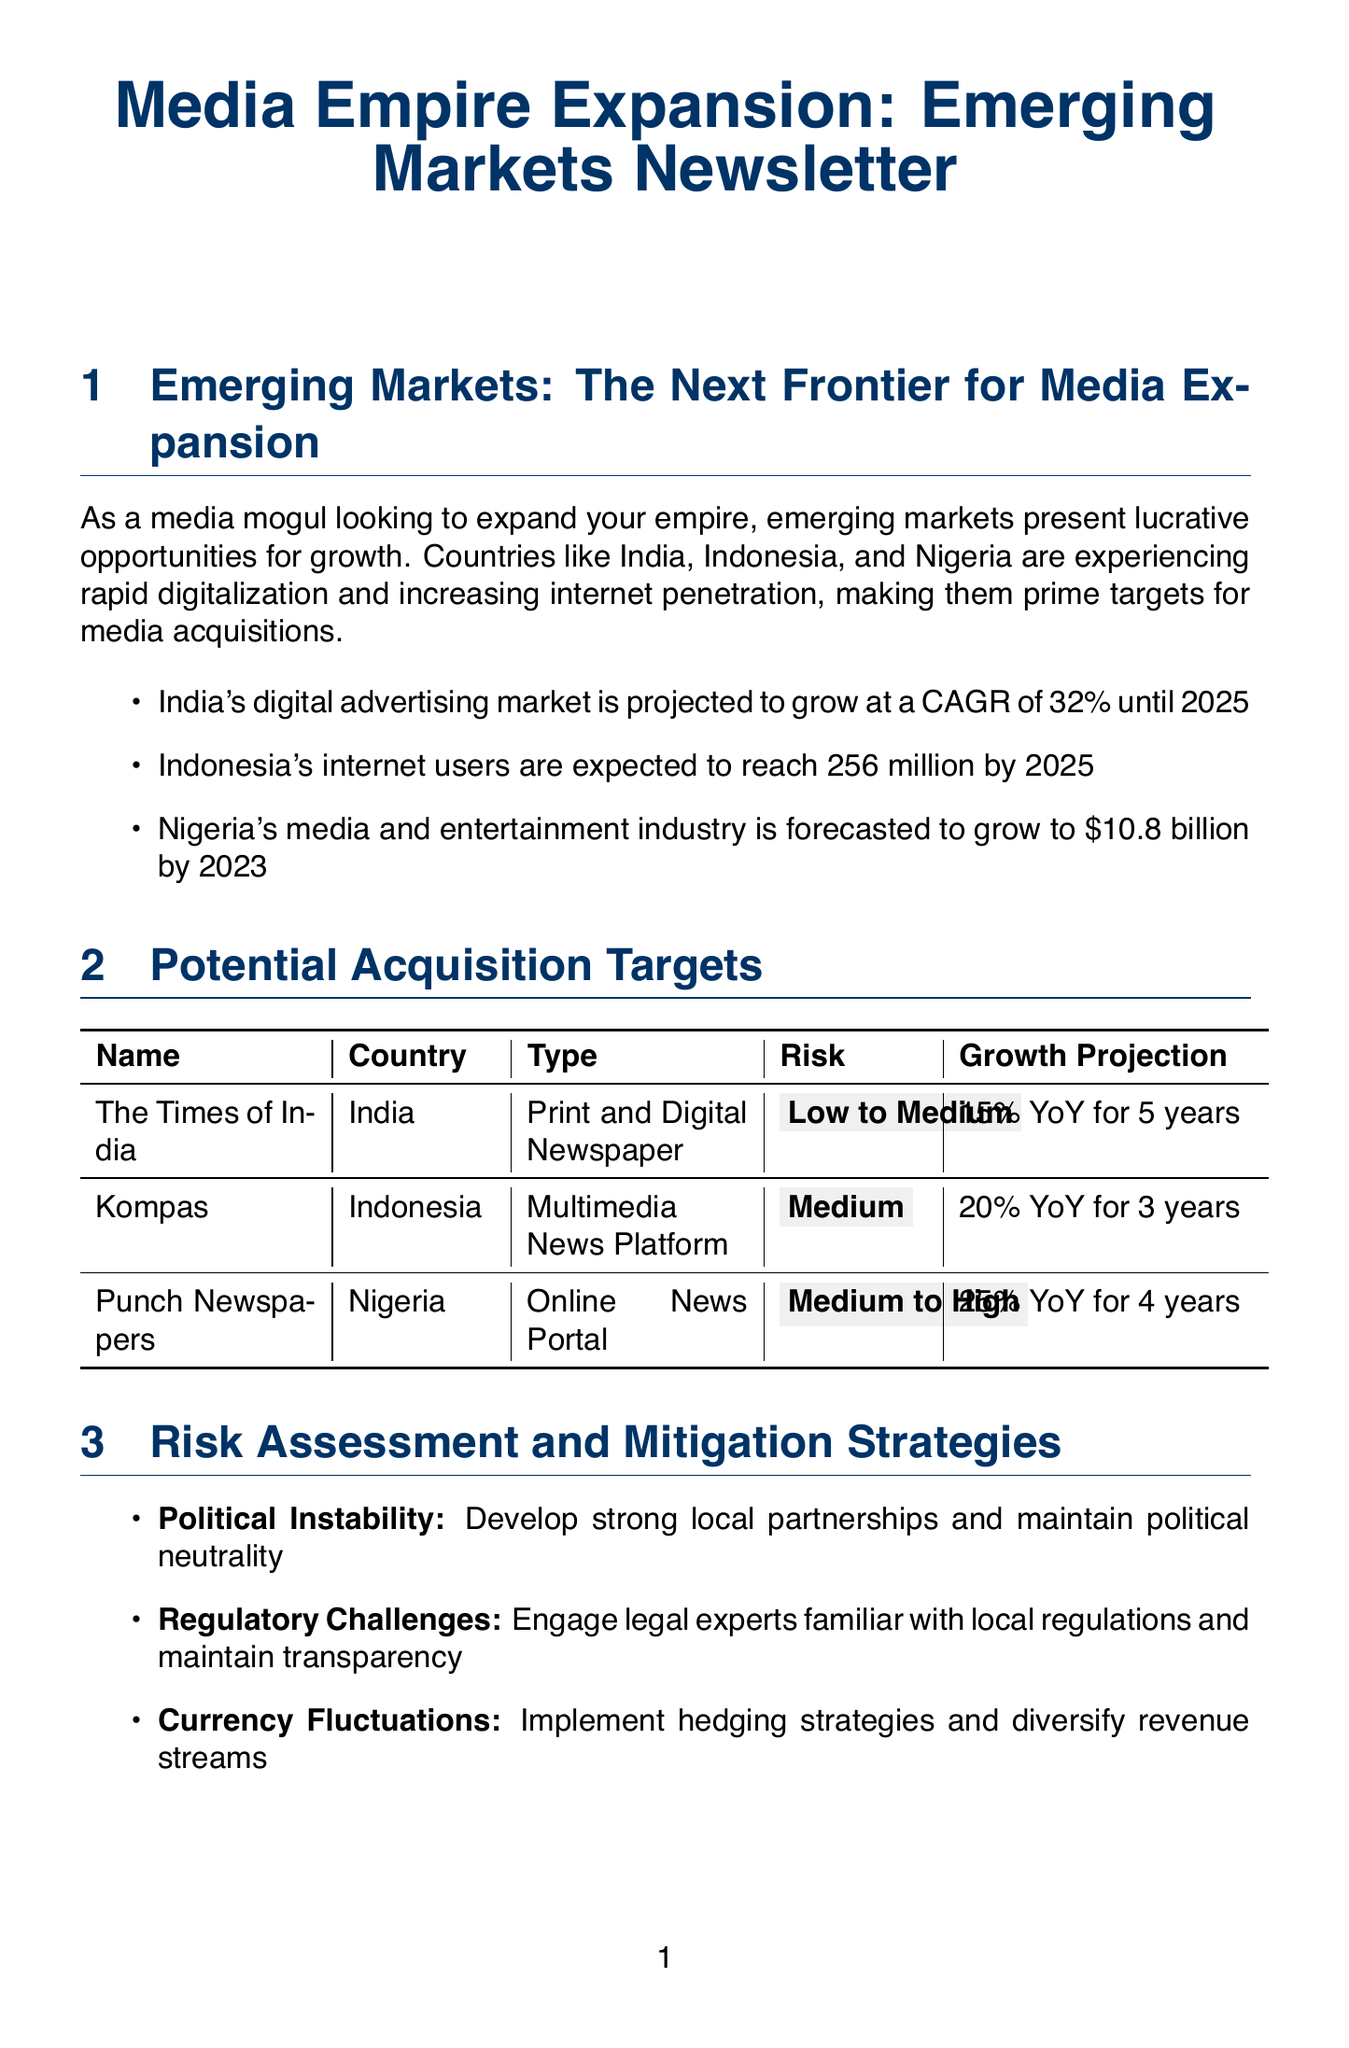What is the projected growth rate of India's digital advertising market? The document states that India's digital advertising market is projected to grow at a CAGR of 32% until 2025.
Answer: 32% What is the expected revenue of Nigeria's media and entertainment industry by 2023? The document forecasts Nigeria's media and entertainment industry to grow to $10.8 billion by 2023.
Answer: $10.8 billion What is the risk assessment for Kompas in Indonesia? The document categorizes the risk assessment for Kompas as Medium.
Answer: Medium What is the growth projection for Punch Newspapers in Nigeria? The document indicates a growth projection of 25% YoY for Punch Newspapers over the next 4 years.
Answer: 25% YoY for 4 years Which country is home to The Times of India? The document specifies that The Times of India is based in India.
Answer: India What are the key drivers for expected ROI in Nigeria? The document notes that the key drivers in Nigeria include mobile-first strategies and podcast advertising.
Answer: Mobile-first strategies, podcast advertising What legal aspect should one consider related to foreign ownership restrictions? The document highlights foreign ownership restrictions in media sectors as a significant legal consideration.
Answer: Foreign ownership restrictions Which firm is recommended for legal due diligence? The document recommends Skadden, Arps, Slate, Meagher & Flom LLP for comprehensive legal due diligence.
Answer: Skadden, Arps, Slate, Meagher & Flom LLP What is the 5-year CAGR projection for Indonesia? The document states that the 5-year CAGR projection for Indonesia is 15%.
Answer: 15% 